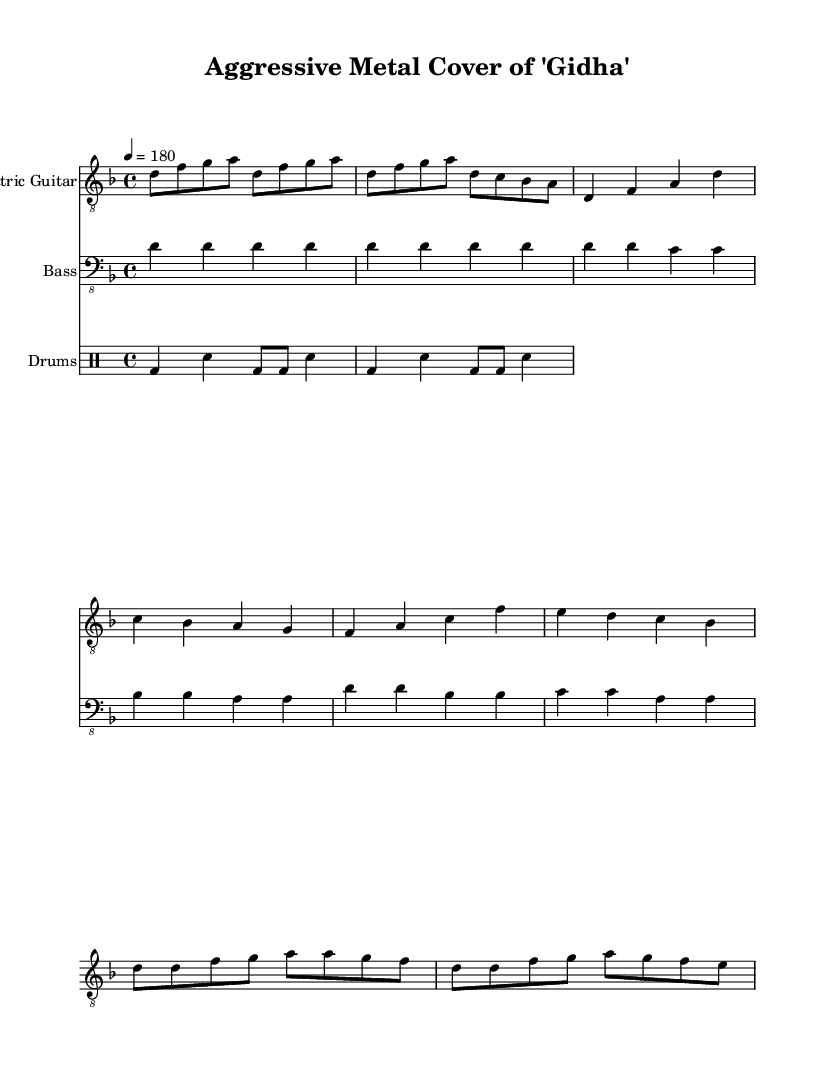What is the key signature of this music? The key signature is indicated by the placement of the sharps or flats at the beginning of the staff. In this case, "d" is shown without any sharps or flats next to it, indicating that it is in D minor.
Answer: D minor What is the time signature of the piece? The time signature is found in the beginning section of the sheet music, where "4/4" is displayed. This means that there are four beats in each measure, and the quarter note gets one beat.
Answer: 4/4 What is the tempo marking for this music? The tempo is indicated numerically in the music sheet as "4 = 180". This means that the quarter note is to be played at a speed of 180 beats per minute, setting a fast-paced rhythm typical in aggressive metal.
Answer: 180 How many measures are there in the verse section? To figure this out, one would need to count the individual segments that represent the verses in the sheet music. The verse has four distinct measures based on the notation provided under the "Verse" marking.
Answer: 4 What type of drum pattern is used in this music? The drum section is indicated with a clear pattern that fits within the basic rock beat structure. Specifically, it shows feedback with bass drum and snare placements, typical for the energy found in metal. This can be interpreted as a basic rock beat pattern.
Answer: Basic rock beat What is the name of the instrument playing the lead? The lead part in the music is labeled as the "Electric Guitar", which is indicated at the start of the respective staff where the guitar notes are written.
Answer: Electric Guitar Which section includes a rapid series of eighth notes? The Chorus section displays several eighth notes, especially where it transitions with faster rhythms, making it a key feature of the aggressive sound typical in metal styles. Specifically, measures beginning with "d8 d" show this structure.
Answer: Chorus 